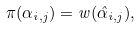<formula> <loc_0><loc_0><loc_500><loc_500>\pi ( \alpha _ { i , j } ) = w ( \hat { \alpha } _ { i , j } ) ,</formula> 